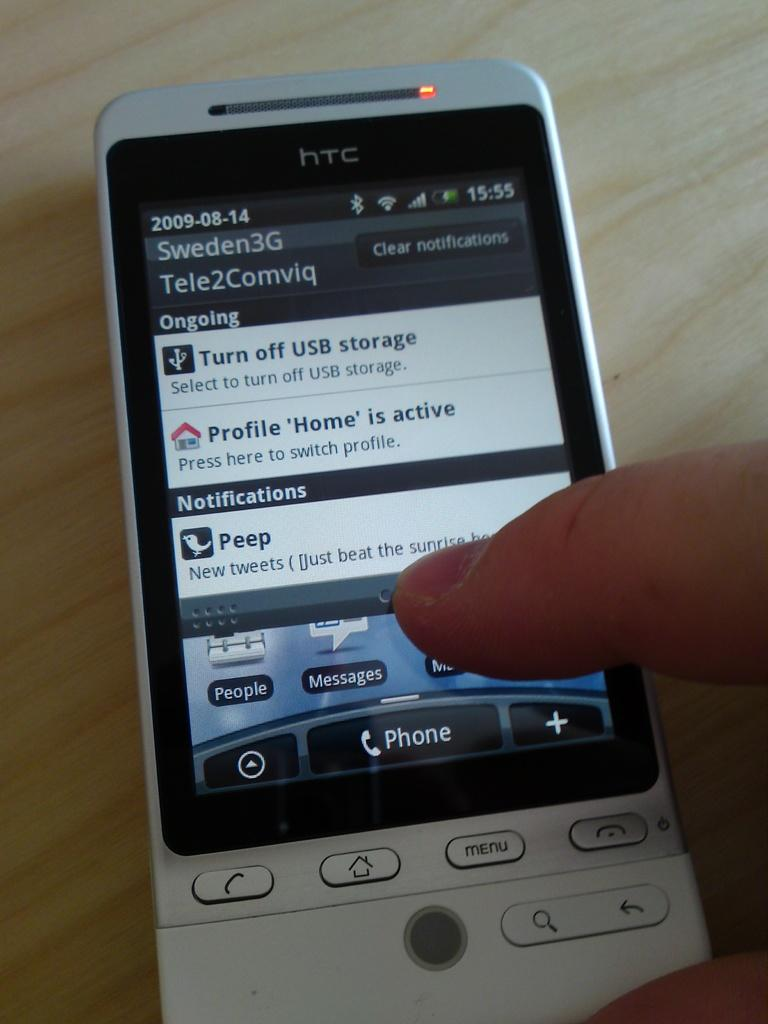Provide a one-sentence caption for the provided image. A gray and black HTC cell phone with a finger pointed on the screen. 